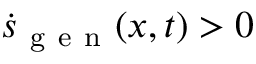<formula> <loc_0><loc_0><loc_500><loc_500>\dot { s } _ { g e n } ( x , t ) > 0</formula> 